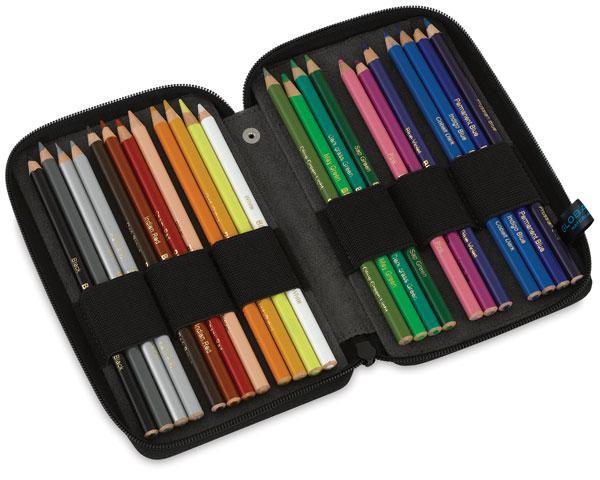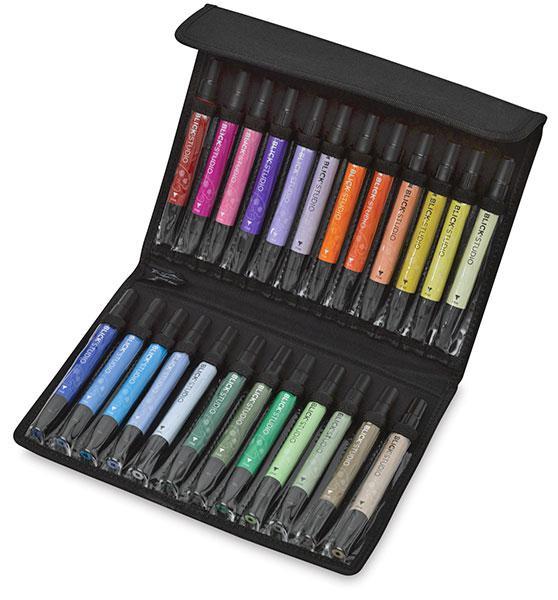The first image is the image on the left, the second image is the image on the right. Evaluate the accuracy of this statement regarding the images: "One binder is displayed upright with its three filled sections fanned out and each section shorter than it is wide.". Is it true? Answer yes or no. No. 